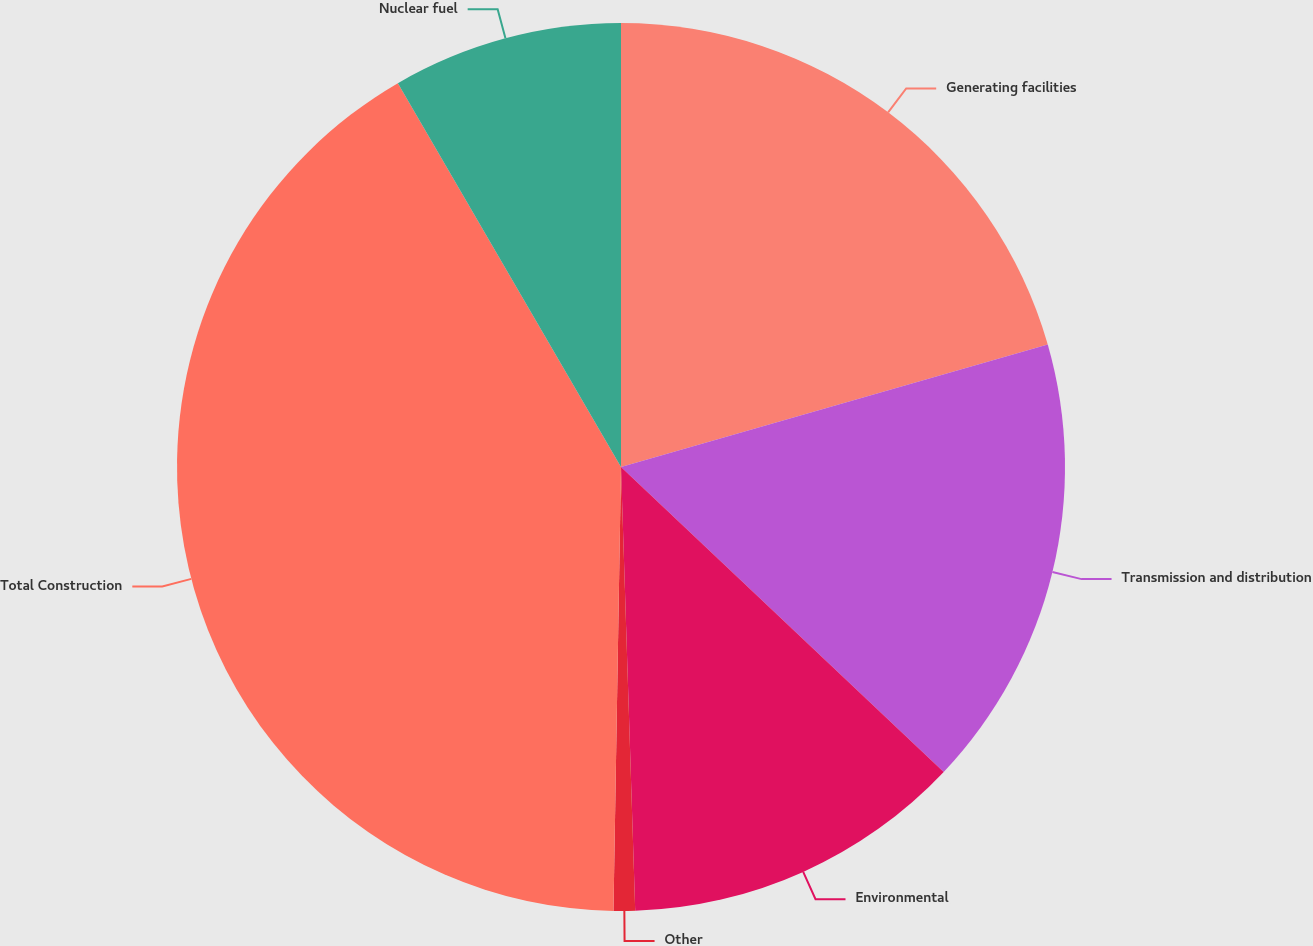Convert chart. <chart><loc_0><loc_0><loc_500><loc_500><pie_chart><fcel>Generating facilities<fcel>Transmission and distribution<fcel>Environmental<fcel>Other<fcel>Total Construction<fcel>Nuclear fuel<nl><fcel>20.55%<fcel>16.5%<fcel>12.44%<fcel>0.78%<fcel>41.35%<fcel>8.38%<nl></chart> 